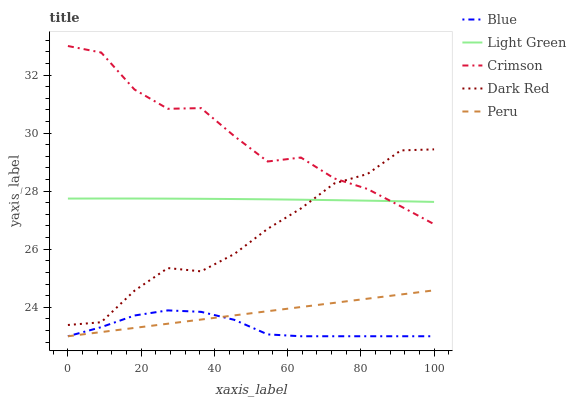Does Blue have the minimum area under the curve?
Answer yes or no. Yes. Does Crimson have the maximum area under the curve?
Answer yes or no. Yes. Does Peru have the minimum area under the curve?
Answer yes or no. No. Does Peru have the maximum area under the curve?
Answer yes or no. No. Is Peru the smoothest?
Answer yes or no. Yes. Is Crimson the roughest?
Answer yes or no. Yes. Is Crimson the smoothest?
Answer yes or no. No. Is Peru the roughest?
Answer yes or no. No. Does Blue have the lowest value?
Answer yes or no. Yes. Does Crimson have the lowest value?
Answer yes or no. No. Does Crimson have the highest value?
Answer yes or no. Yes. Does Peru have the highest value?
Answer yes or no. No. Is Blue less than Light Green?
Answer yes or no. Yes. Is Dark Red greater than Peru?
Answer yes or no. Yes. Does Dark Red intersect Light Green?
Answer yes or no. Yes. Is Dark Red less than Light Green?
Answer yes or no. No. Is Dark Red greater than Light Green?
Answer yes or no. No. Does Blue intersect Light Green?
Answer yes or no. No. 